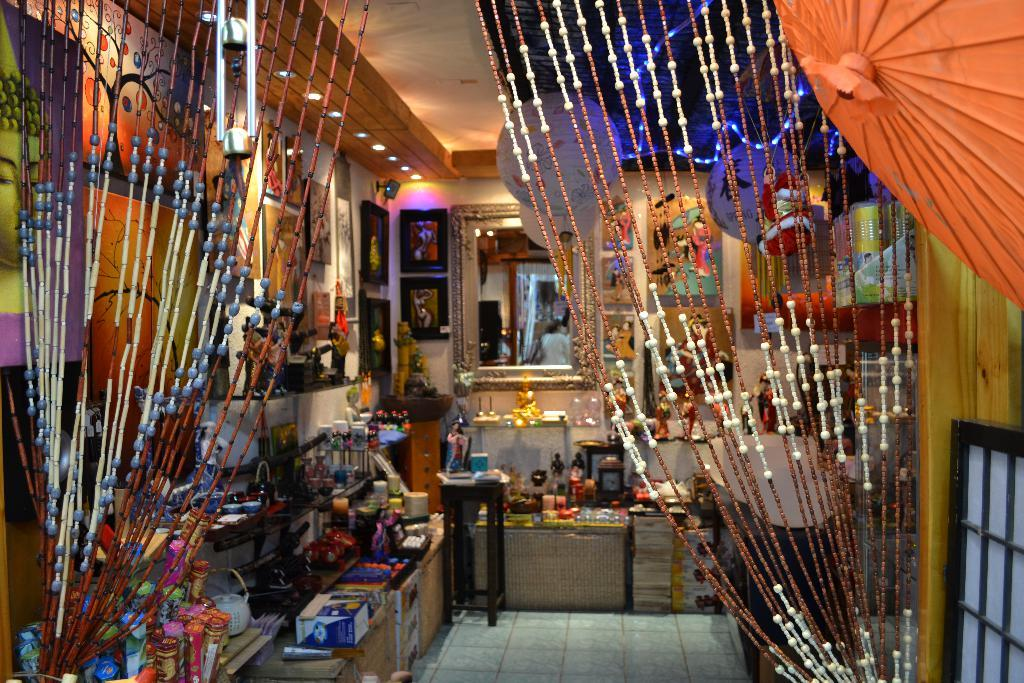What types of items can be seen in the image? There are decorative items in the image. Where are some of the objects placed in the image? Some objects are placed on shelves in the image. What can be seen hanging on the wall in the image? There are photo frames on the wall in the image. What is a reflective item present in the image? There is a mirror in the image. What type of lighting is visible in the background of the image? There are ceiling lights in the background of the image. What type of pot is used for watering plants in the image? There is no pot or plants visible in the image. What health benefits are mentioned in the image? There is no mention of health or health benefits in the image. 